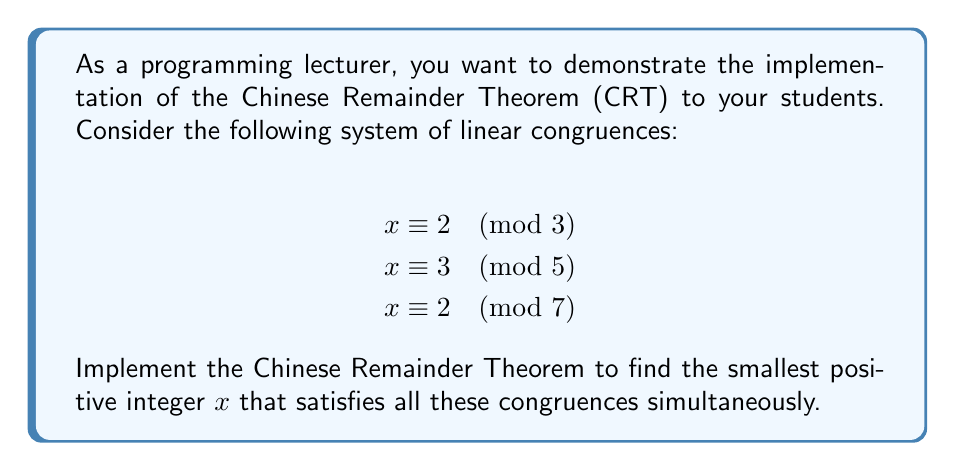Show me your answer to this math problem. To solve this system using the Chinese Remainder Theorem, we'll follow these steps:

1) First, calculate the product of all moduli:
   $M = 3 \times 5 \times 7 = 105$

2) For each congruence, calculate $M_i = M / m_i$:
   $M_1 = 105 / 3 = 35$
   $M_2 = 105 / 5 = 21$
   $M_3 = 105 / 7 = 15$

3) Find the modular multiplicative inverse of each $M_i$ modulo $m_i$:
   $35^{-1} \equiv 2 \pmod{3}$
   $21^{-1} \equiv 1 \pmod{5}$
   $15^{-1} \equiv 1 \pmod{7}$

4) Calculate the solution:
   $x = (a_1 \times M_1 \times M_1^{-1} + a_2 \times M_2 \times M_2^{-1} + a_3 \times M_3 \times M_3^{-1}) \pmod{M}$
   
   $x = (2 \times 35 \times 2 + 3 \times 21 \times 1 + 2 \times 15 \times 1) \pmod{105}$
   
   $x = (140 + 63 + 30) \pmod{105}$
   
   $x = 233 \pmod{105}$
   
   $x = 23$

5) Verify the solution:
   $23 \equiv 2 \pmod{3}$
   $23 \equiv 3 \pmod{5}$
   $23 \equiv 2 \pmod{7}$

Therefore, the smallest positive integer $x$ that satisfies all the congruences is 23.
Answer: 23 